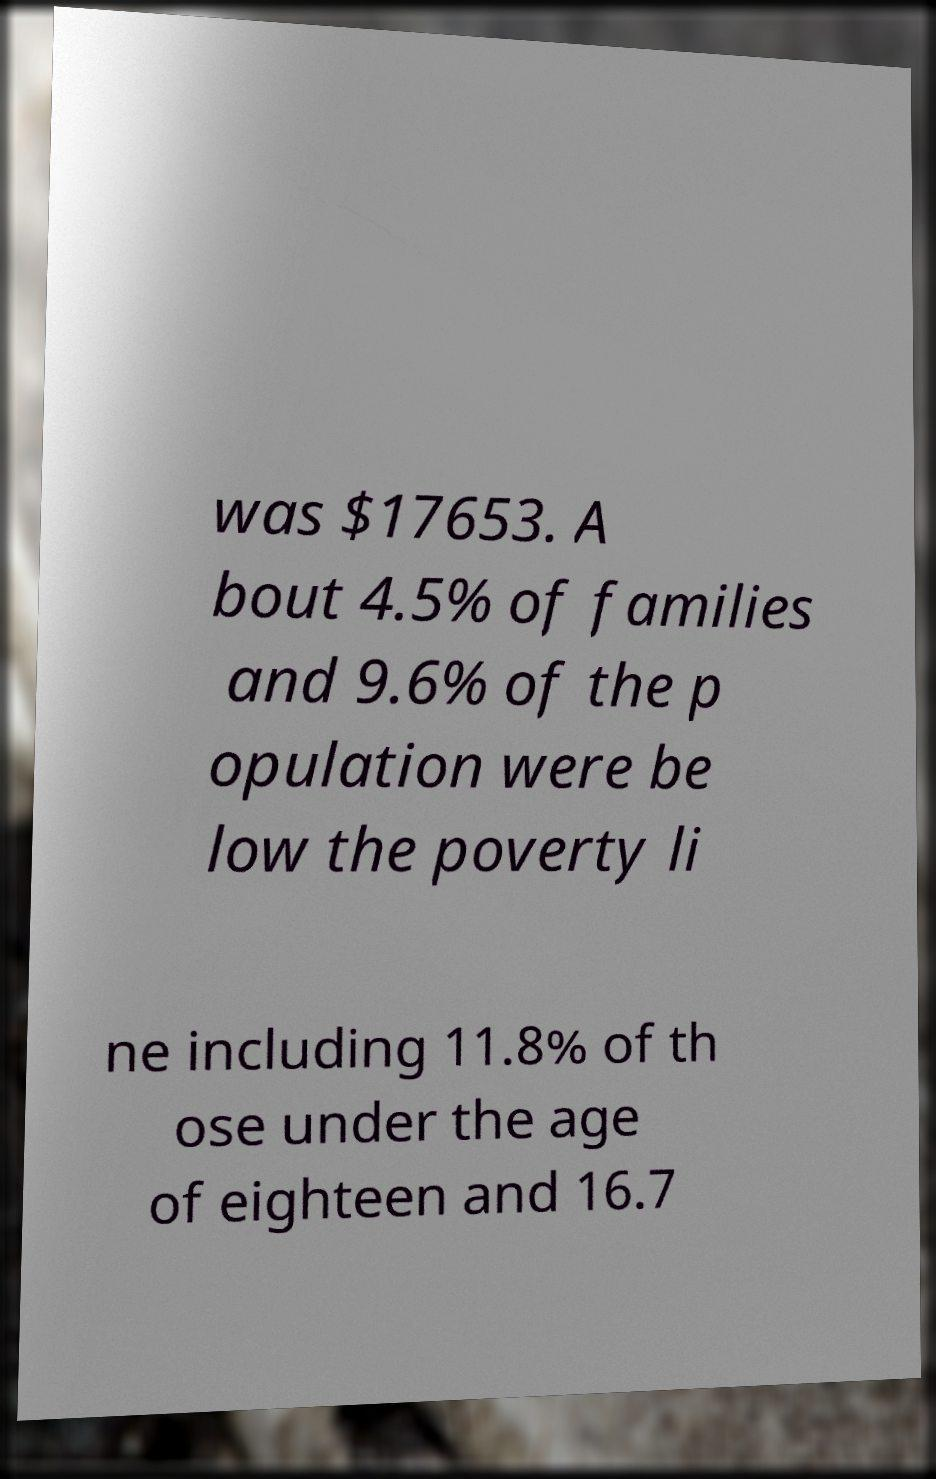There's text embedded in this image that I need extracted. Can you transcribe it verbatim? was $17653. A bout 4.5% of families and 9.6% of the p opulation were be low the poverty li ne including 11.8% of th ose under the age of eighteen and 16.7 